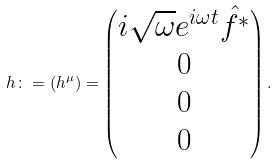<formula> <loc_0><loc_0><loc_500><loc_500>h \colon = ( h ^ { \mu } ) = \begin{pmatrix} i \sqrt { \omega } e ^ { i \omega t } \hat { f ^ { * } } \\ 0 \\ 0 \\ 0 \end{pmatrix} .</formula> 